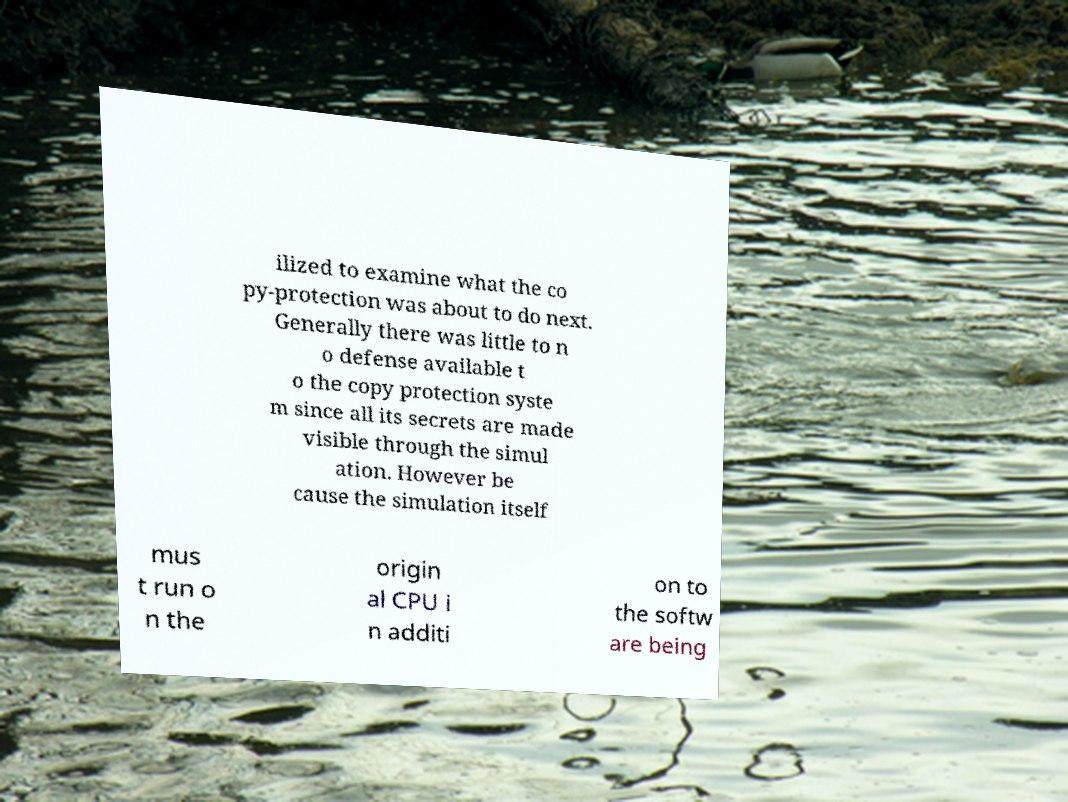Could you assist in decoding the text presented in this image and type it out clearly? ilized to examine what the co py-protection was about to do next. Generally there was little to n o defense available t o the copy protection syste m since all its secrets are made visible through the simul ation. However be cause the simulation itself mus t run o n the origin al CPU i n additi on to the softw are being 